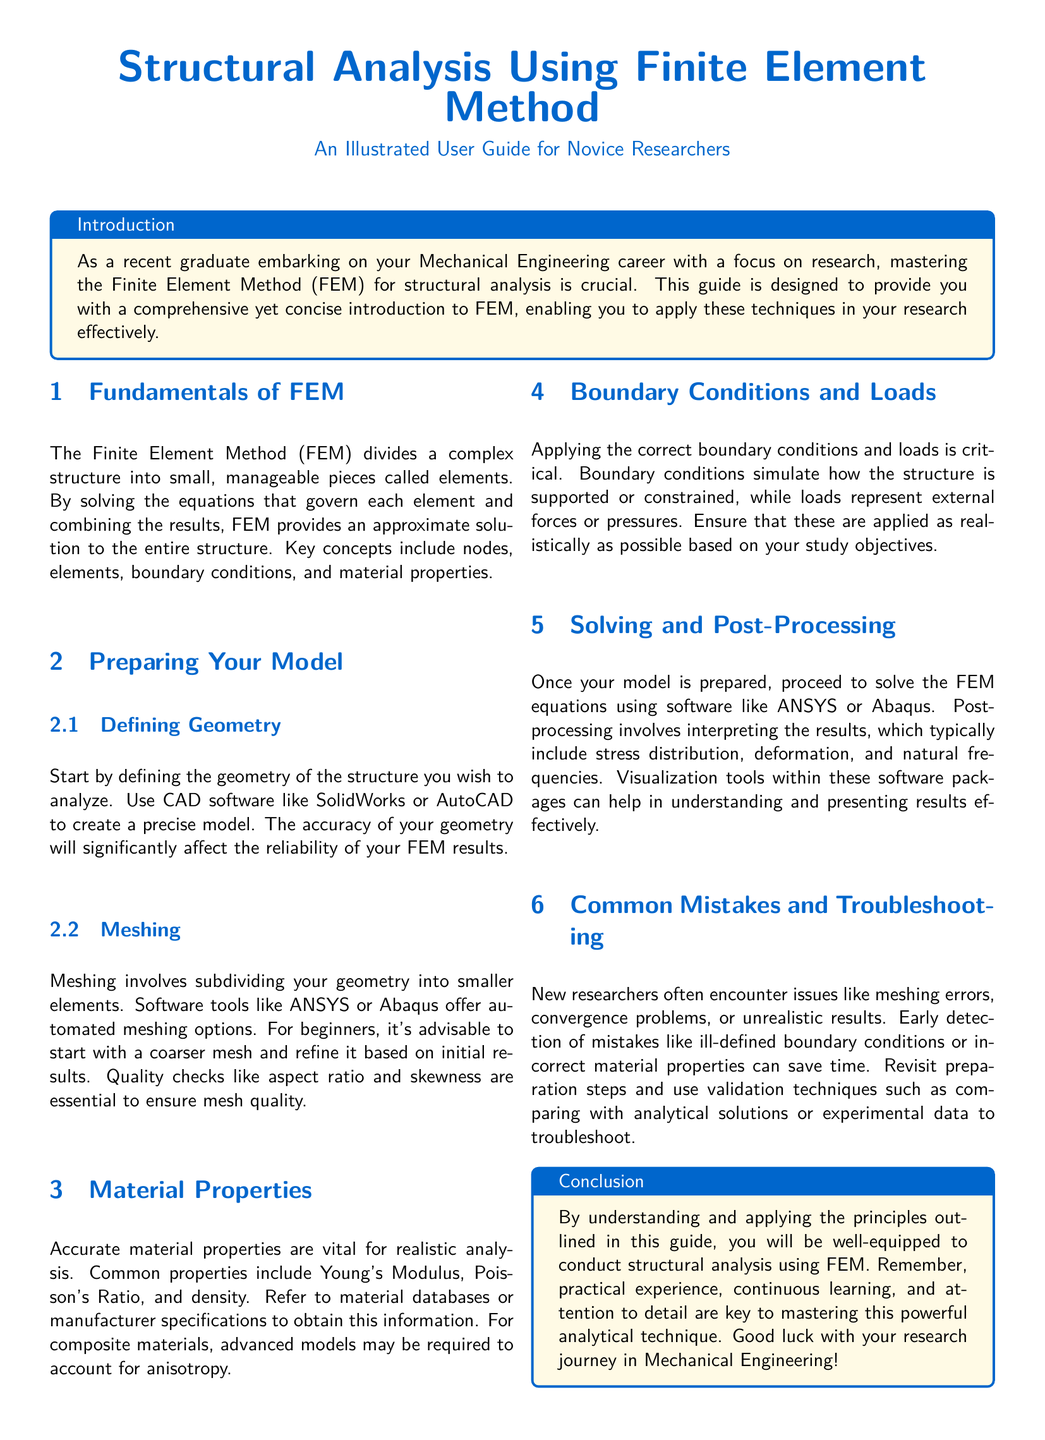What does FEM stand for? FEM is an abbreviation commonly used in the document referring to the Finite Element Method, which is a technique used for structural analysis.
Answer: Finite Element Method What is suggested for defining geometry? The document recommends using CAD software like SolidWorks or AutoCAD to create a precise model of the structure before analysis.
Answer: CAD software Which software is mentioned for solving FEM equations? The guide references ANSYS or Abaqus as suitable software tools for solving the FEM equations.
Answer: ANSYS or Abaqus What should be checked for mesh quality? Essential checks for mesh quality include aspect ratio and skewness.
Answer: Aspect ratio and skewness What is a common mistake made by new researchers? A common mistake mentioned is the use of ill-defined boundary conditions, which can lead to errors in the analysis.
Answer: Ill-defined boundary conditions What are key material properties needed for analysis? The key material properties required include Young's Modulus, Poisson's Ratio, and density.
Answer: Young's Modulus, Poisson's Ratio, and density What is the primary objective of applying boundary conditions? Boundary conditions simulate how the structure is supported or constrained during analysis.
Answer: Supported or constrained What is an important part of the post-processing step? Interpretation of the results, including stress distribution and deformation, is an important aspect of post-processing.
Answer: Stress distribution and deformation What aspect does the user guide emphasize for mastering FEM? The guide emphasizes practical experience, continuous learning, and attention to detail for mastering FEM.
Answer: Practical experience, continuous learning, attention to detail 